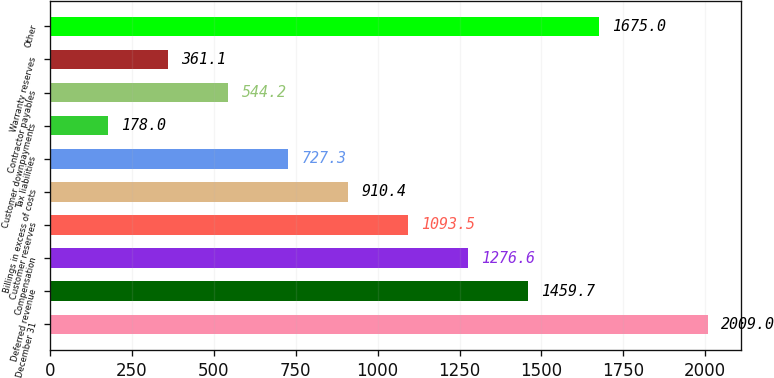<chart> <loc_0><loc_0><loc_500><loc_500><bar_chart><fcel>December 31<fcel>Deferred revenue<fcel>Compensation<fcel>Customer reserves<fcel>Billings in excess of costs<fcel>Tax liabilities<fcel>Customer downpayments<fcel>Contractor payables<fcel>Warranty reserves<fcel>Other<nl><fcel>2009<fcel>1459.7<fcel>1276.6<fcel>1093.5<fcel>910.4<fcel>727.3<fcel>178<fcel>544.2<fcel>361.1<fcel>1675<nl></chart> 